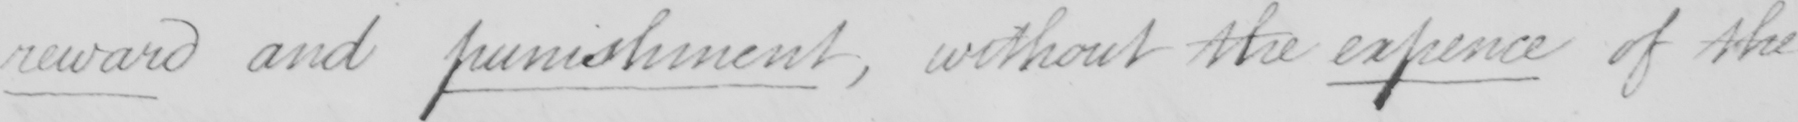Can you read and transcribe this handwriting? reward and punishment , without the expence of the 